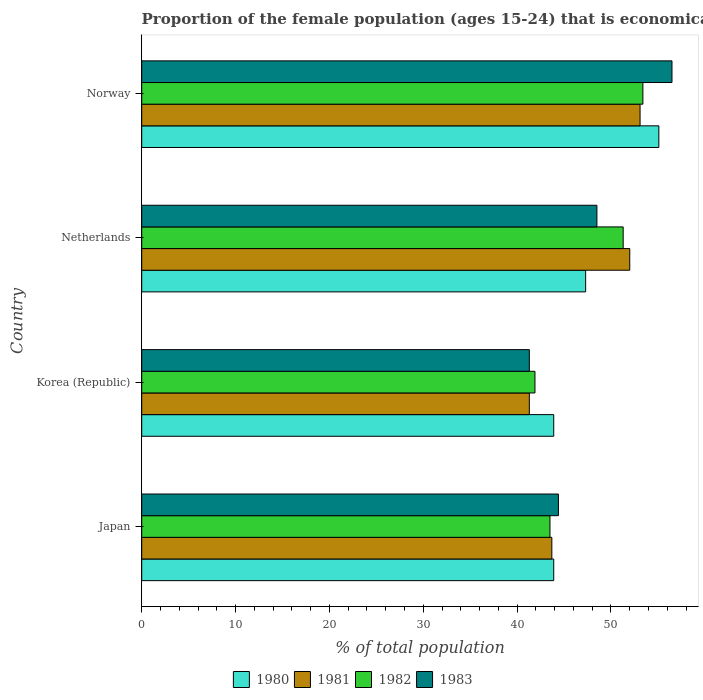Are the number of bars per tick equal to the number of legend labels?
Your answer should be very brief. Yes. Are the number of bars on each tick of the Y-axis equal?
Your answer should be compact. Yes. How many bars are there on the 2nd tick from the top?
Your answer should be very brief. 4. How many bars are there on the 4th tick from the bottom?
Keep it short and to the point. 4. In how many cases, is the number of bars for a given country not equal to the number of legend labels?
Ensure brevity in your answer.  0. What is the proportion of the female population that is economically active in 1981 in Norway?
Your response must be concise. 53.1. Across all countries, what is the maximum proportion of the female population that is economically active in 1983?
Ensure brevity in your answer.  56.5. Across all countries, what is the minimum proportion of the female population that is economically active in 1980?
Ensure brevity in your answer.  43.9. In which country was the proportion of the female population that is economically active in 1982 maximum?
Your answer should be compact. Norway. In which country was the proportion of the female population that is economically active in 1983 minimum?
Provide a succinct answer. Korea (Republic). What is the total proportion of the female population that is economically active in 1981 in the graph?
Give a very brief answer. 190.1. What is the difference between the proportion of the female population that is economically active in 1983 in Japan and that in Korea (Republic)?
Provide a short and direct response. 3.1. What is the difference between the proportion of the female population that is economically active in 1980 in Netherlands and the proportion of the female population that is economically active in 1982 in Norway?
Your response must be concise. -6.1. What is the average proportion of the female population that is economically active in 1980 per country?
Your answer should be compact. 47.55. What is the difference between the proportion of the female population that is economically active in 1981 and proportion of the female population that is economically active in 1982 in Japan?
Keep it short and to the point. 0.2. What is the ratio of the proportion of the female population that is economically active in 1980 in Korea (Republic) to that in Norway?
Offer a terse response. 0.8. What is the difference between the highest and the lowest proportion of the female population that is economically active in 1980?
Give a very brief answer. 11.2. Is the sum of the proportion of the female population that is economically active in 1981 in Japan and Korea (Republic) greater than the maximum proportion of the female population that is economically active in 1983 across all countries?
Provide a succinct answer. Yes. What does the 4th bar from the top in Japan represents?
Make the answer very short. 1980. Is it the case that in every country, the sum of the proportion of the female population that is economically active in 1982 and proportion of the female population that is economically active in 1983 is greater than the proportion of the female population that is economically active in 1981?
Provide a short and direct response. Yes. Are all the bars in the graph horizontal?
Give a very brief answer. Yes. What is the difference between two consecutive major ticks on the X-axis?
Your answer should be very brief. 10. Does the graph contain any zero values?
Your answer should be very brief. No. Where does the legend appear in the graph?
Make the answer very short. Bottom center. How are the legend labels stacked?
Your answer should be compact. Horizontal. What is the title of the graph?
Give a very brief answer. Proportion of the female population (ages 15-24) that is economically active. Does "1982" appear as one of the legend labels in the graph?
Make the answer very short. Yes. What is the label or title of the X-axis?
Your answer should be very brief. % of total population. What is the label or title of the Y-axis?
Your response must be concise. Country. What is the % of total population in 1980 in Japan?
Provide a succinct answer. 43.9. What is the % of total population of 1981 in Japan?
Make the answer very short. 43.7. What is the % of total population of 1982 in Japan?
Give a very brief answer. 43.5. What is the % of total population of 1983 in Japan?
Your answer should be very brief. 44.4. What is the % of total population of 1980 in Korea (Republic)?
Make the answer very short. 43.9. What is the % of total population in 1981 in Korea (Republic)?
Keep it short and to the point. 41.3. What is the % of total population of 1982 in Korea (Republic)?
Offer a terse response. 41.9. What is the % of total population in 1983 in Korea (Republic)?
Ensure brevity in your answer.  41.3. What is the % of total population in 1980 in Netherlands?
Provide a succinct answer. 47.3. What is the % of total population in 1981 in Netherlands?
Offer a terse response. 52. What is the % of total population in 1982 in Netherlands?
Offer a terse response. 51.3. What is the % of total population in 1983 in Netherlands?
Keep it short and to the point. 48.5. What is the % of total population of 1980 in Norway?
Your answer should be compact. 55.1. What is the % of total population in 1981 in Norway?
Make the answer very short. 53.1. What is the % of total population in 1982 in Norway?
Provide a short and direct response. 53.4. What is the % of total population of 1983 in Norway?
Provide a succinct answer. 56.5. Across all countries, what is the maximum % of total population of 1980?
Keep it short and to the point. 55.1. Across all countries, what is the maximum % of total population of 1981?
Keep it short and to the point. 53.1. Across all countries, what is the maximum % of total population of 1982?
Make the answer very short. 53.4. Across all countries, what is the maximum % of total population of 1983?
Give a very brief answer. 56.5. Across all countries, what is the minimum % of total population of 1980?
Your response must be concise. 43.9. Across all countries, what is the minimum % of total population in 1981?
Make the answer very short. 41.3. Across all countries, what is the minimum % of total population of 1982?
Ensure brevity in your answer.  41.9. Across all countries, what is the minimum % of total population of 1983?
Ensure brevity in your answer.  41.3. What is the total % of total population in 1980 in the graph?
Your answer should be compact. 190.2. What is the total % of total population of 1981 in the graph?
Your answer should be very brief. 190.1. What is the total % of total population in 1982 in the graph?
Offer a terse response. 190.1. What is the total % of total population of 1983 in the graph?
Offer a very short reply. 190.7. What is the difference between the % of total population in 1980 in Japan and that in Korea (Republic)?
Ensure brevity in your answer.  0. What is the difference between the % of total population of 1982 in Japan and that in Korea (Republic)?
Offer a terse response. 1.6. What is the difference between the % of total population in 1980 in Japan and that in Netherlands?
Offer a terse response. -3.4. What is the difference between the % of total population in 1981 in Japan and that in Netherlands?
Offer a terse response. -8.3. What is the difference between the % of total population in 1983 in Japan and that in Netherlands?
Provide a succinct answer. -4.1. What is the difference between the % of total population of 1980 in Japan and that in Norway?
Your response must be concise. -11.2. What is the difference between the % of total population in 1981 in Japan and that in Norway?
Offer a terse response. -9.4. What is the difference between the % of total population of 1980 in Korea (Republic) and that in Netherlands?
Provide a succinct answer. -3.4. What is the difference between the % of total population in 1982 in Korea (Republic) and that in Netherlands?
Offer a very short reply. -9.4. What is the difference between the % of total population in 1983 in Korea (Republic) and that in Netherlands?
Give a very brief answer. -7.2. What is the difference between the % of total population of 1980 in Korea (Republic) and that in Norway?
Your answer should be very brief. -11.2. What is the difference between the % of total population of 1982 in Korea (Republic) and that in Norway?
Provide a short and direct response. -11.5. What is the difference between the % of total population in 1983 in Korea (Republic) and that in Norway?
Offer a very short reply. -15.2. What is the difference between the % of total population of 1981 in Netherlands and that in Norway?
Ensure brevity in your answer.  -1.1. What is the difference between the % of total population in 1982 in Netherlands and that in Norway?
Give a very brief answer. -2.1. What is the difference between the % of total population in 1983 in Netherlands and that in Norway?
Give a very brief answer. -8. What is the difference between the % of total population in 1980 in Japan and the % of total population in 1982 in Korea (Republic)?
Offer a terse response. 2. What is the difference between the % of total population of 1982 in Japan and the % of total population of 1983 in Korea (Republic)?
Offer a very short reply. 2.2. What is the difference between the % of total population of 1980 in Japan and the % of total population of 1982 in Netherlands?
Give a very brief answer. -7.4. What is the difference between the % of total population of 1980 in Japan and the % of total population of 1983 in Netherlands?
Make the answer very short. -4.6. What is the difference between the % of total population of 1981 in Japan and the % of total population of 1983 in Netherlands?
Provide a short and direct response. -4.8. What is the difference between the % of total population of 1982 in Japan and the % of total population of 1983 in Netherlands?
Provide a succinct answer. -5. What is the difference between the % of total population of 1980 in Japan and the % of total population of 1982 in Norway?
Offer a very short reply. -9.5. What is the difference between the % of total population in 1980 in Japan and the % of total population in 1983 in Norway?
Offer a terse response. -12.6. What is the difference between the % of total population of 1981 in Japan and the % of total population of 1982 in Norway?
Make the answer very short. -9.7. What is the difference between the % of total population of 1982 in Japan and the % of total population of 1983 in Norway?
Your answer should be compact. -13. What is the difference between the % of total population in 1980 in Korea (Republic) and the % of total population in 1983 in Netherlands?
Offer a terse response. -4.6. What is the difference between the % of total population of 1982 in Korea (Republic) and the % of total population of 1983 in Netherlands?
Offer a terse response. -6.6. What is the difference between the % of total population in 1980 in Korea (Republic) and the % of total population in 1981 in Norway?
Offer a terse response. -9.2. What is the difference between the % of total population of 1980 in Korea (Republic) and the % of total population of 1982 in Norway?
Offer a terse response. -9.5. What is the difference between the % of total population of 1980 in Korea (Republic) and the % of total population of 1983 in Norway?
Ensure brevity in your answer.  -12.6. What is the difference between the % of total population of 1981 in Korea (Republic) and the % of total population of 1982 in Norway?
Your response must be concise. -12.1. What is the difference between the % of total population of 1981 in Korea (Republic) and the % of total population of 1983 in Norway?
Your answer should be very brief. -15.2. What is the difference between the % of total population in 1982 in Korea (Republic) and the % of total population in 1983 in Norway?
Provide a succinct answer. -14.6. What is the difference between the % of total population in 1980 in Netherlands and the % of total population in 1981 in Norway?
Provide a succinct answer. -5.8. What is the difference between the % of total population of 1980 in Netherlands and the % of total population of 1983 in Norway?
Provide a short and direct response. -9.2. What is the difference between the % of total population of 1981 in Netherlands and the % of total population of 1983 in Norway?
Give a very brief answer. -4.5. What is the difference between the % of total population in 1982 in Netherlands and the % of total population in 1983 in Norway?
Give a very brief answer. -5.2. What is the average % of total population in 1980 per country?
Your answer should be compact. 47.55. What is the average % of total population of 1981 per country?
Your answer should be very brief. 47.52. What is the average % of total population in 1982 per country?
Your answer should be very brief. 47.52. What is the average % of total population in 1983 per country?
Ensure brevity in your answer.  47.67. What is the difference between the % of total population of 1980 and % of total population of 1983 in Japan?
Provide a succinct answer. -0.5. What is the difference between the % of total population in 1981 and % of total population in 1982 in Japan?
Your answer should be compact. 0.2. What is the difference between the % of total population of 1982 and % of total population of 1983 in Japan?
Ensure brevity in your answer.  -0.9. What is the difference between the % of total population in 1980 and % of total population in 1981 in Korea (Republic)?
Your answer should be compact. 2.6. What is the difference between the % of total population in 1980 and % of total population in 1983 in Korea (Republic)?
Give a very brief answer. 2.6. What is the difference between the % of total population in 1981 and % of total population in 1983 in Korea (Republic)?
Your response must be concise. 0. What is the difference between the % of total population of 1982 and % of total population of 1983 in Netherlands?
Give a very brief answer. 2.8. What is the difference between the % of total population in 1980 and % of total population in 1982 in Norway?
Offer a terse response. 1.7. What is the difference between the % of total population of 1981 and % of total population of 1982 in Norway?
Make the answer very short. -0.3. What is the ratio of the % of total population in 1981 in Japan to that in Korea (Republic)?
Keep it short and to the point. 1.06. What is the ratio of the % of total population in 1982 in Japan to that in Korea (Republic)?
Your answer should be compact. 1.04. What is the ratio of the % of total population in 1983 in Japan to that in Korea (Republic)?
Your answer should be very brief. 1.08. What is the ratio of the % of total population in 1980 in Japan to that in Netherlands?
Keep it short and to the point. 0.93. What is the ratio of the % of total population of 1981 in Japan to that in Netherlands?
Your response must be concise. 0.84. What is the ratio of the % of total population in 1982 in Japan to that in Netherlands?
Offer a terse response. 0.85. What is the ratio of the % of total population in 1983 in Japan to that in Netherlands?
Provide a short and direct response. 0.92. What is the ratio of the % of total population in 1980 in Japan to that in Norway?
Keep it short and to the point. 0.8. What is the ratio of the % of total population of 1981 in Japan to that in Norway?
Provide a succinct answer. 0.82. What is the ratio of the % of total population of 1982 in Japan to that in Norway?
Ensure brevity in your answer.  0.81. What is the ratio of the % of total population of 1983 in Japan to that in Norway?
Ensure brevity in your answer.  0.79. What is the ratio of the % of total population in 1980 in Korea (Republic) to that in Netherlands?
Give a very brief answer. 0.93. What is the ratio of the % of total population in 1981 in Korea (Republic) to that in Netherlands?
Provide a short and direct response. 0.79. What is the ratio of the % of total population of 1982 in Korea (Republic) to that in Netherlands?
Your answer should be very brief. 0.82. What is the ratio of the % of total population of 1983 in Korea (Republic) to that in Netherlands?
Offer a very short reply. 0.85. What is the ratio of the % of total population in 1980 in Korea (Republic) to that in Norway?
Make the answer very short. 0.8. What is the ratio of the % of total population in 1981 in Korea (Republic) to that in Norway?
Provide a short and direct response. 0.78. What is the ratio of the % of total population of 1982 in Korea (Republic) to that in Norway?
Ensure brevity in your answer.  0.78. What is the ratio of the % of total population of 1983 in Korea (Republic) to that in Norway?
Ensure brevity in your answer.  0.73. What is the ratio of the % of total population of 1980 in Netherlands to that in Norway?
Your answer should be very brief. 0.86. What is the ratio of the % of total population of 1981 in Netherlands to that in Norway?
Offer a very short reply. 0.98. What is the ratio of the % of total population in 1982 in Netherlands to that in Norway?
Provide a short and direct response. 0.96. What is the ratio of the % of total population of 1983 in Netherlands to that in Norway?
Offer a terse response. 0.86. What is the difference between the highest and the second highest % of total population in 1980?
Give a very brief answer. 7.8. What is the difference between the highest and the second highest % of total population in 1982?
Keep it short and to the point. 2.1. What is the difference between the highest and the lowest % of total population of 1980?
Provide a short and direct response. 11.2. What is the difference between the highest and the lowest % of total population of 1982?
Give a very brief answer. 11.5. What is the difference between the highest and the lowest % of total population of 1983?
Offer a very short reply. 15.2. 